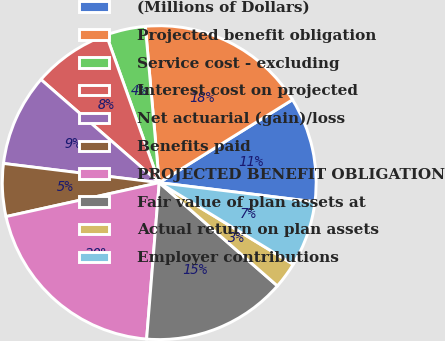Convert chart to OTSL. <chart><loc_0><loc_0><loc_500><loc_500><pie_chart><fcel>(Millions of Dollars)<fcel>Projected benefit obligation<fcel>Service cost - excluding<fcel>Interest cost on projected<fcel>Net actuarial (gain)/loss<fcel>Benefits paid<fcel>PROJECTED BENEFIT OBLIGATION<fcel>Fair value of plan assets at<fcel>Actual return on plan assets<fcel>Employer contributions<nl><fcel>10.81%<fcel>17.55%<fcel>4.07%<fcel>8.11%<fcel>9.46%<fcel>5.42%<fcel>20.25%<fcel>14.85%<fcel>2.72%<fcel>6.76%<nl></chart> 